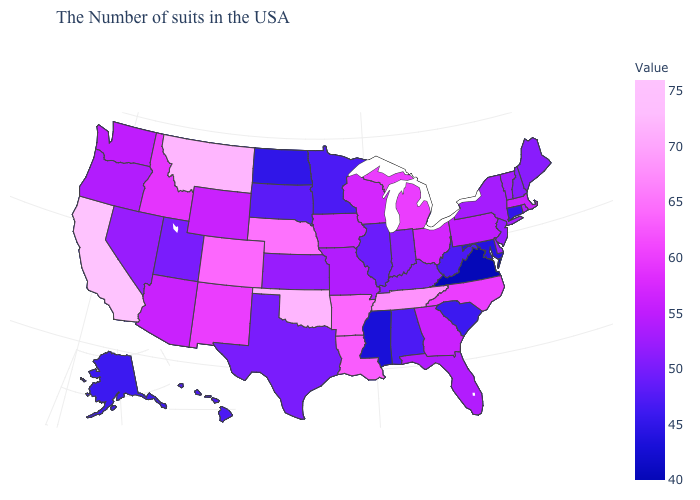Among the states that border North Carolina , which have the highest value?
Be succinct. Tennessee. Among the states that border Florida , which have the lowest value?
Answer briefly. Alabama. Does Colorado have the highest value in the USA?
Write a very short answer. No. Does Iowa have the lowest value in the MidWest?
Concise answer only. No. Does Rhode Island have the lowest value in the Northeast?
Quick response, please. No. Among the states that border West Virginia , does Ohio have the lowest value?
Answer briefly. No. 